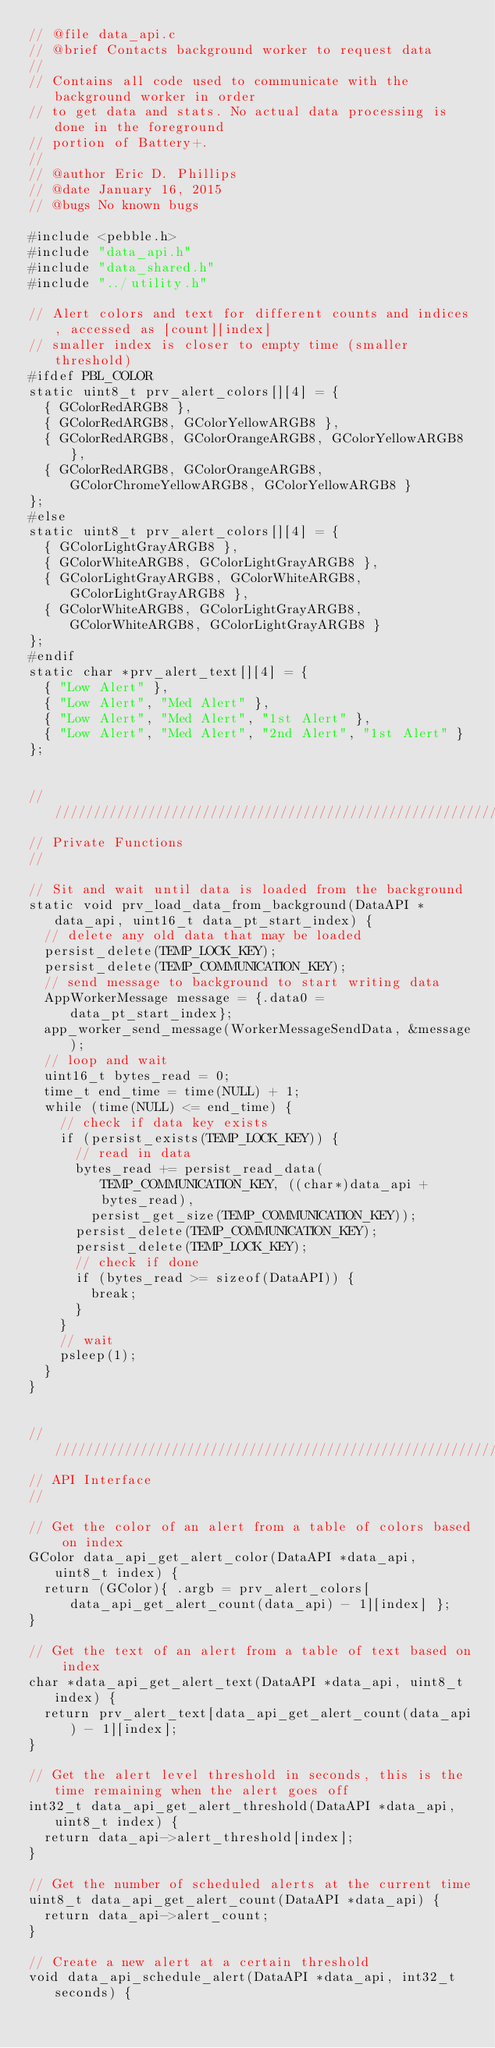Convert code to text. <code><loc_0><loc_0><loc_500><loc_500><_C_>// @file data_api.c
// @brief Contacts background worker to request data
//
// Contains all code used to communicate with the background worker in order
// to get data and stats. No actual data processing is done in the foreground
// portion of Battery+.
//
// @author Eric D. Phillips
// @date January 16, 2015
// @bugs No known bugs

#include <pebble.h>
#include "data_api.h"
#include "data_shared.h"
#include "../utility.h"

// Alert colors and text for different counts and indices, accessed as [count][index]
// smaller index is closer to empty time (smaller threshold)
#ifdef PBL_COLOR
static uint8_t prv_alert_colors[][4] = {
  { GColorRedARGB8 },
  { GColorRedARGB8, GColorYellowARGB8 },
  { GColorRedARGB8, GColorOrangeARGB8, GColorYellowARGB8 },
  { GColorRedARGB8, GColorOrangeARGB8, GColorChromeYellowARGB8, GColorYellowARGB8 }
};
#else
static uint8_t prv_alert_colors[][4] = {
  { GColorLightGrayARGB8 },
  { GColorWhiteARGB8, GColorLightGrayARGB8 },
  { GColorLightGrayARGB8, GColorWhiteARGB8, GColorLightGrayARGB8 },
  { GColorWhiteARGB8, GColorLightGrayARGB8, GColorWhiteARGB8, GColorLightGrayARGB8 }
};
#endif
static char *prv_alert_text[][4] = {
  { "Low Alert" },
  { "Low Alert", "Med Alert" },
  { "Low Alert", "Med Alert", "1st Alert" },
  { "Low Alert", "Med Alert", "2nd Alert", "1st Alert" }
};


////////////////////////////////////////////////////////////////////////////////////////////////////
// Private Functions
//

// Sit and wait until data is loaded from the background
static void prv_load_data_from_background(DataAPI *data_api, uint16_t data_pt_start_index) {
  // delete any old data that may be loaded
  persist_delete(TEMP_LOCK_KEY);
  persist_delete(TEMP_COMMUNICATION_KEY);
  // send message to background to start writing data
  AppWorkerMessage message = {.data0 = data_pt_start_index};
  app_worker_send_message(WorkerMessageSendData, &message);
  // loop and wait
  uint16_t bytes_read = 0;
  time_t end_time = time(NULL) + 1;
  while (time(NULL) <= end_time) {
    // check if data key exists
    if (persist_exists(TEMP_LOCK_KEY)) {
      // read in data
      bytes_read += persist_read_data(TEMP_COMMUNICATION_KEY, ((char*)data_api + bytes_read),
        persist_get_size(TEMP_COMMUNICATION_KEY));
      persist_delete(TEMP_COMMUNICATION_KEY);
      persist_delete(TEMP_LOCK_KEY);
      // check if done
      if (bytes_read >= sizeof(DataAPI)) {
        break;
      }
    }
    // wait
    psleep(1);
  }
}


////////////////////////////////////////////////////////////////////////////////////////////////////
// API Interface
//

// Get the color of an alert from a table of colors based on index
GColor data_api_get_alert_color(DataAPI *data_api, uint8_t index) {
  return (GColor){ .argb = prv_alert_colors[data_api_get_alert_count(data_api) - 1][index] };
}

// Get the text of an alert from a table of text based on index
char *data_api_get_alert_text(DataAPI *data_api, uint8_t index) {
  return prv_alert_text[data_api_get_alert_count(data_api) - 1][index];
}

// Get the alert level threshold in seconds, this is the time remaining when the alert goes off
int32_t data_api_get_alert_threshold(DataAPI *data_api, uint8_t index) {
  return data_api->alert_threshold[index];
}

// Get the number of scheduled alerts at the current time
uint8_t data_api_get_alert_count(DataAPI *data_api) {
  return data_api->alert_count;
}

// Create a new alert at a certain threshold
void data_api_schedule_alert(DataAPI *data_api, int32_t seconds) {</code> 